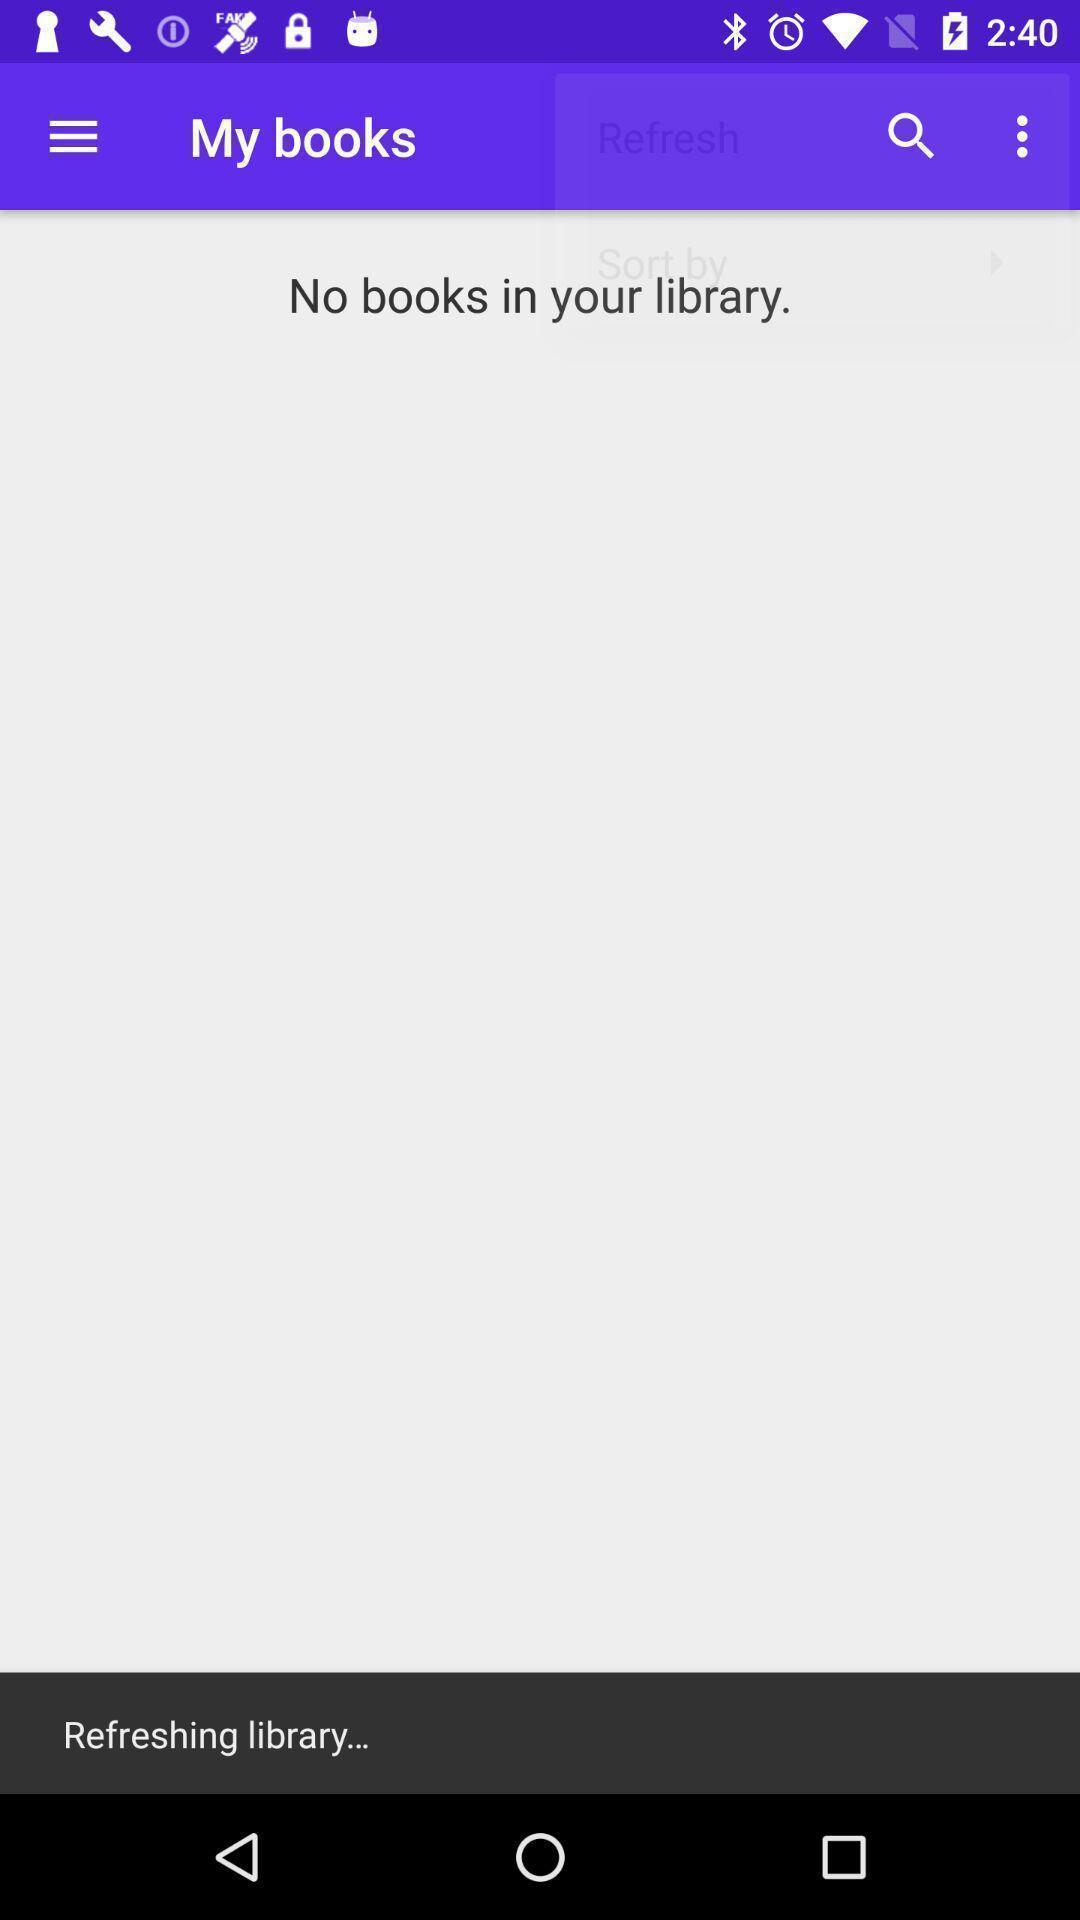Tell me what you see in this picture. Search page displaying library option in learning app. 